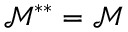Convert formula to latex. <formula><loc_0><loc_0><loc_500><loc_500>\mathcal { M } ^ { \ast \ast } = \mathcal { M }</formula> 